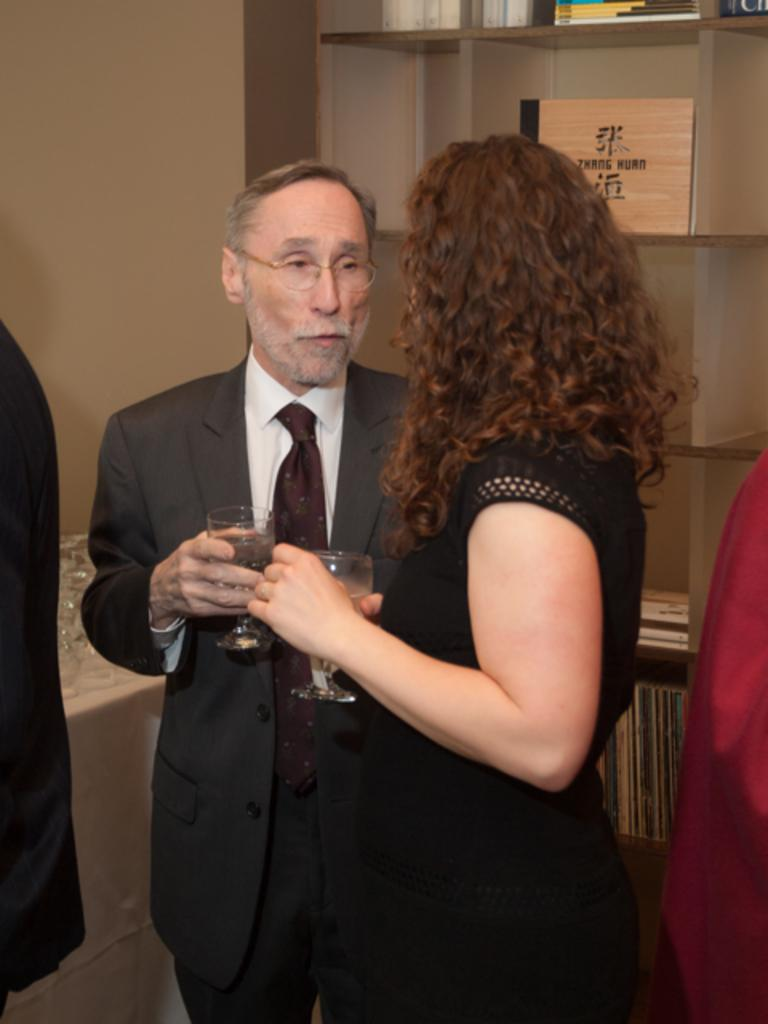How many people are in the image? There are two persons standing in the image. What are the persons holding in their hands? Both persons are holding glasses. What can be seen in the background of the image? There are bookshelves in the background of the image. How many books are visible on the bookshelves? The bookshelves contain multiple books. What type of tooth is visible in the image? There is no tooth present in the image. What statement can be made about the persons' accounts in the image? There is no information about the persons' accounts in the image. 